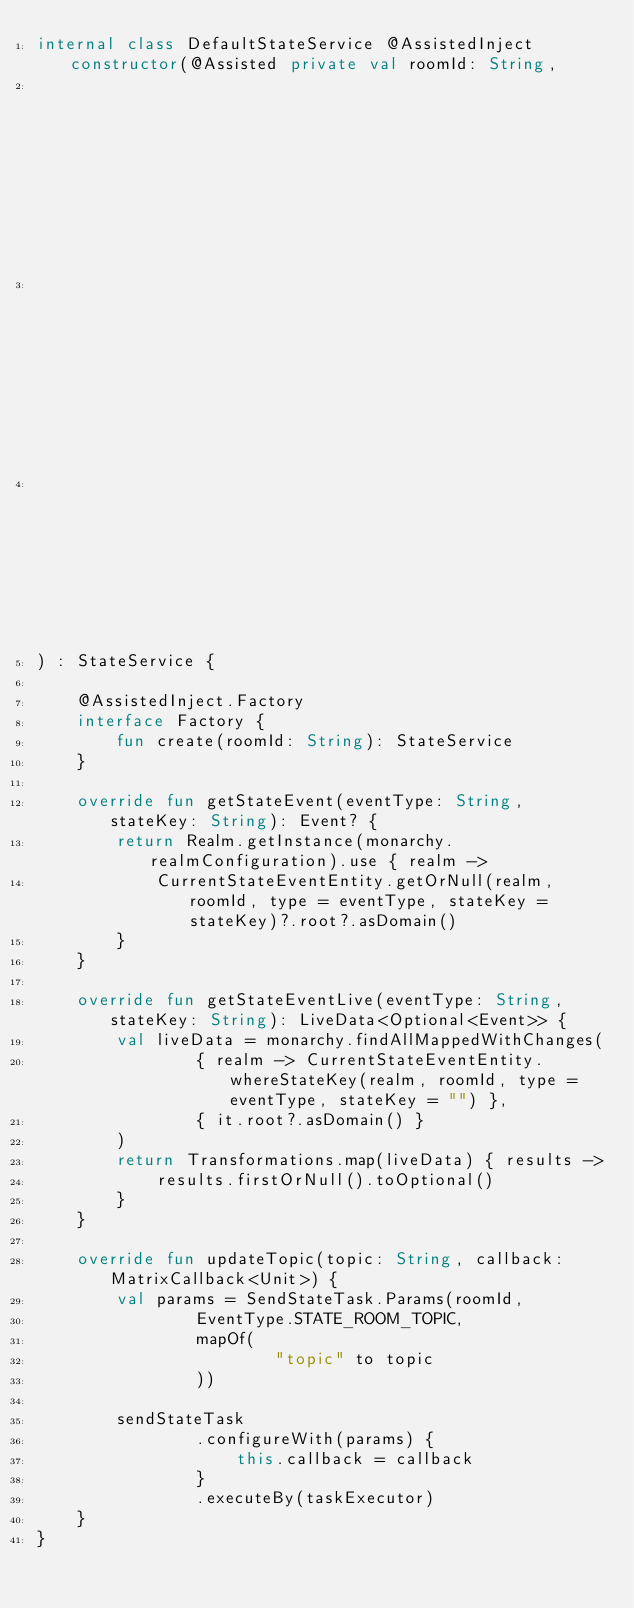<code> <loc_0><loc_0><loc_500><loc_500><_Kotlin_>internal class DefaultStateService @AssistedInject constructor(@Assisted private val roomId: String,
                                                               private val monarchy: Monarchy,
                                                               private val taskExecutor: TaskExecutor,
                                                               private val sendStateTask: SendStateTask
) : StateService {

    @AssistedInject.Factory
    interface Factory {
        fun create(roomId: String): StateService
    }

    override fun getStateEvent(eventType: String, stateKey: String): Event? {
        return Realm.getInstance(monarchy.realmConfiguration).use { realm ->
            CurrentStateEventEntity.getOrNull(realm, roomId, type = eventType, stateKey = stateKey)?.root?.asDomain()
        }
    }

    override fun getStateEventLive(eventType: String, stateKey: String): LiveData<Optional<Event>> {
        val liveData = monarchy.findAllMappedWithChanges(
                { realm -> CurrentStateEventEntity.whereStateKey(realm, roomId, type = eventType, stateKey = "") },
                { it.root?.asDomain() }
        )
        return Transformations.map(liveData) { results ->
            results.firstOrNull().toOptional()
        }
    }

    override fun updateTopic(topic: String, callback: MatrixCallback<Unit>) {
        val params = SendStateTask.Params(roomId,
                EventType.STATE_ROOM_TOPIC,
                mapOf(
                        "topic" to topic
                ))

        sendStateTask
                .configureWith(params) {
                    this.callback = callback
                }
                .executeBy(taskExecutor)
    }
}
</code> 